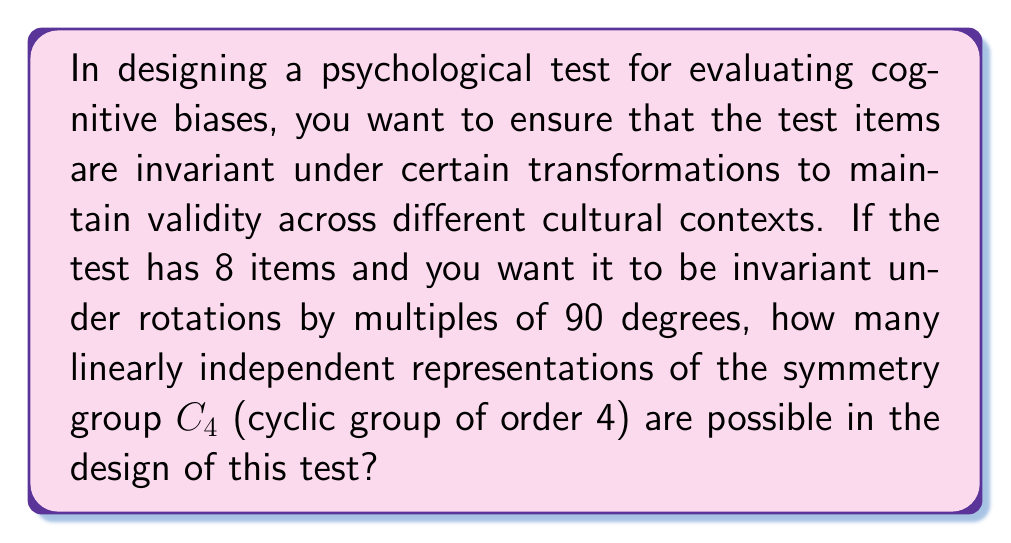Give your solution to this math problem. To solve this problem, we need to follow these steps:

1) First, recall that for a cyclic group of order n, the number of irreducible representations is equal to the number of divisors of n. In this case, C4 has 4 divisors: 1, 2, 4.

2) The dimensions of these irreducible representations are:
   - 1-dimensional: $\chi_0(k) = 1$
   - 1-dimensional: $\chi_1(k) = i^k$
   - 1-dimensional: $\chi_2(k) = (-1)^k$
   - 1-dimensional: $\chi_3(k) = (-i)^k$

3) The total number of linearly independent representations is equal to the number of ways we can decompose the 8-dimensional space into these irreducible representations.

4) This is equivalent to finding the number of solutions to the equation:
   $$a + b + c + d = 8$$
   where $a, b, c, d$ are non-negative integers representing the number of times each irreducible representation appears in the decomposition.

5) This is a classic stars and bars problem in combinatorics. The number of solutions is given by the combination:
   $$\binom{n+k-1}{k-1} = \binom{8+4-1}{4-1} = \binom{11}{3}$$

6) We can calculate this:
   $$\binom{11}{3} = \frac{11!}{3!(11-3)!} = \frac{11 \cdot 10 \cdot 9}{3 \cdot 2 \cdot 1} = 165$$

Therefore, there are 165 possible linearly independent representations of C4 in the design of this 8-item psychological test.
Answer: 165 